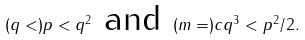<formula> <loc_0><loc_0><loc_500><loc_500>( q < ) p < q ^ { 2 } \ \text {and} \ ( m = ) c q ^ { 3 } < p ^ { 2 } / 2 .</formula> 